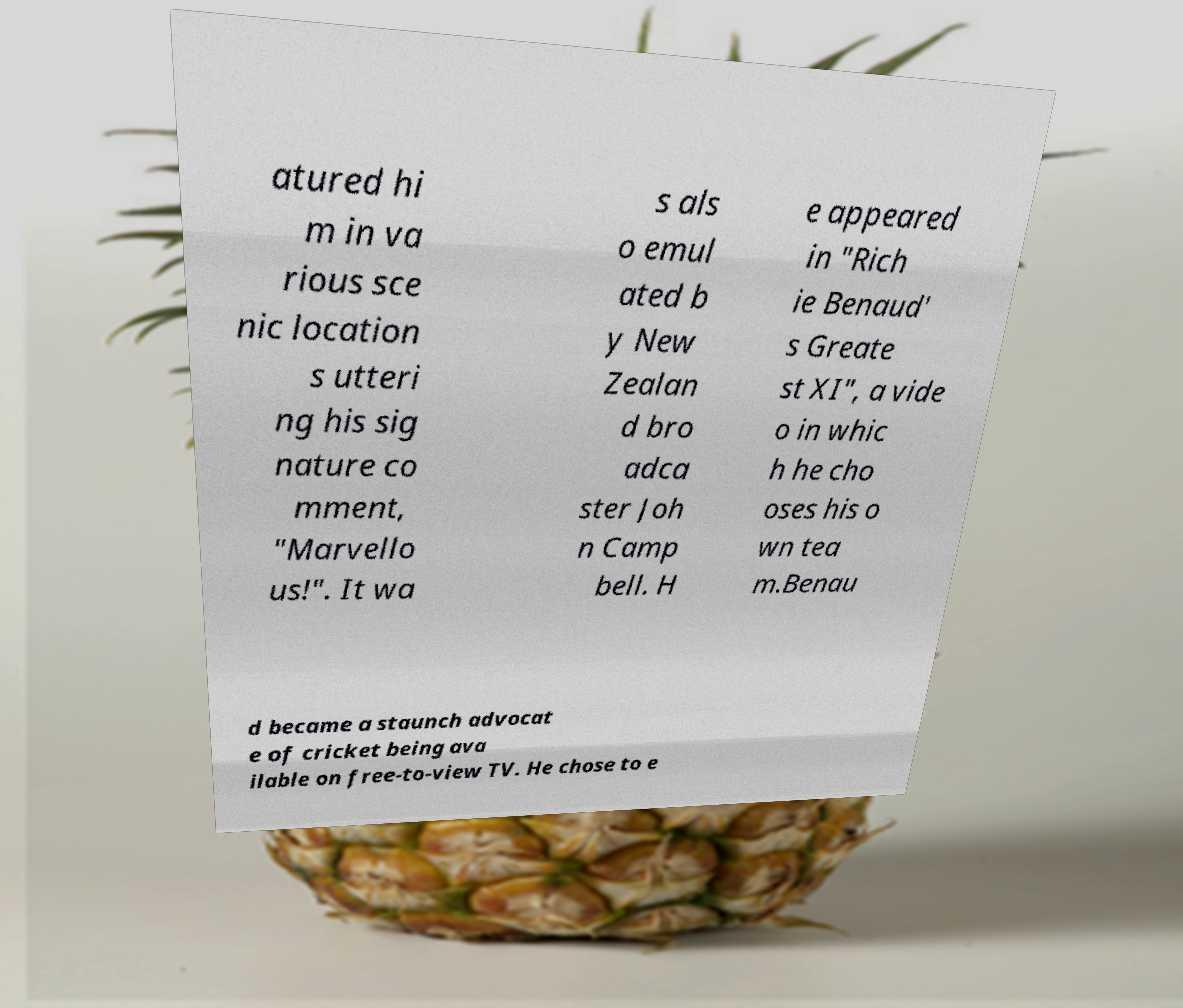There's text embedded in this image that I need extracted. Can you transcribe it verbatim? atured hi m in va rious sce nic location s utteri ng his sig nature co mment, "Marvello us!". It wa s als o emul ated b y New Zealan d bro adca ster Joh n Camp bell. H e appeared in "Rich ie Benaud' s Greate st XI", a vide o in whic h he cho oses his o wn tea m.Benau d became a staunch advocat e of cricket being ava ilable on free-to-view TV. He chose to e 